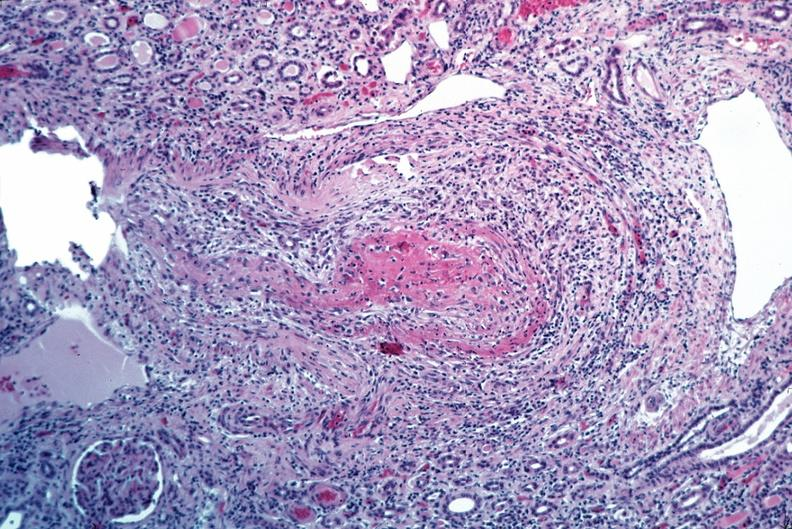s vasculature present?
Answer the question using a single word or phrase. Yes 